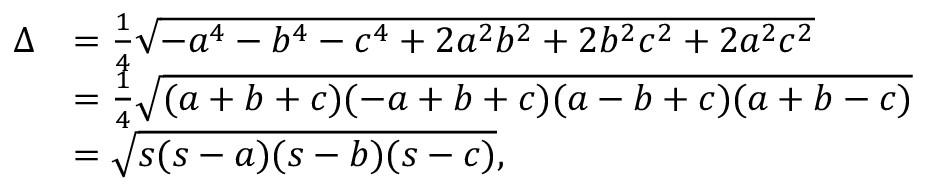Convert formula to latex. <formula><loc_0><loc_0><loc_500><loc_500>{ \begin{array} { r l } { \Delta } & { = { \frac { 1 } { 4 } } { \sqrt { - a ^ { 4 } - b ^ { 4 } - c ^ { 4 } + 2 a ^ { 2 } b ^ { 2 } + 2 b ^ { 2 } c ^ { 2 } + 2 a ^ { 2 } c ^ { 2 } } } } \\ & { = { \frac { 1 } { 4 } } { \sqrt { ( a + b + c ) ( - a + b + c ) ( a - b + c ) ( a + b - c ) } } } \\ & { = { \sqrt { s ( s - a ) ( s - b ) ( s - c ) } } , } \end{array} }</formula> 